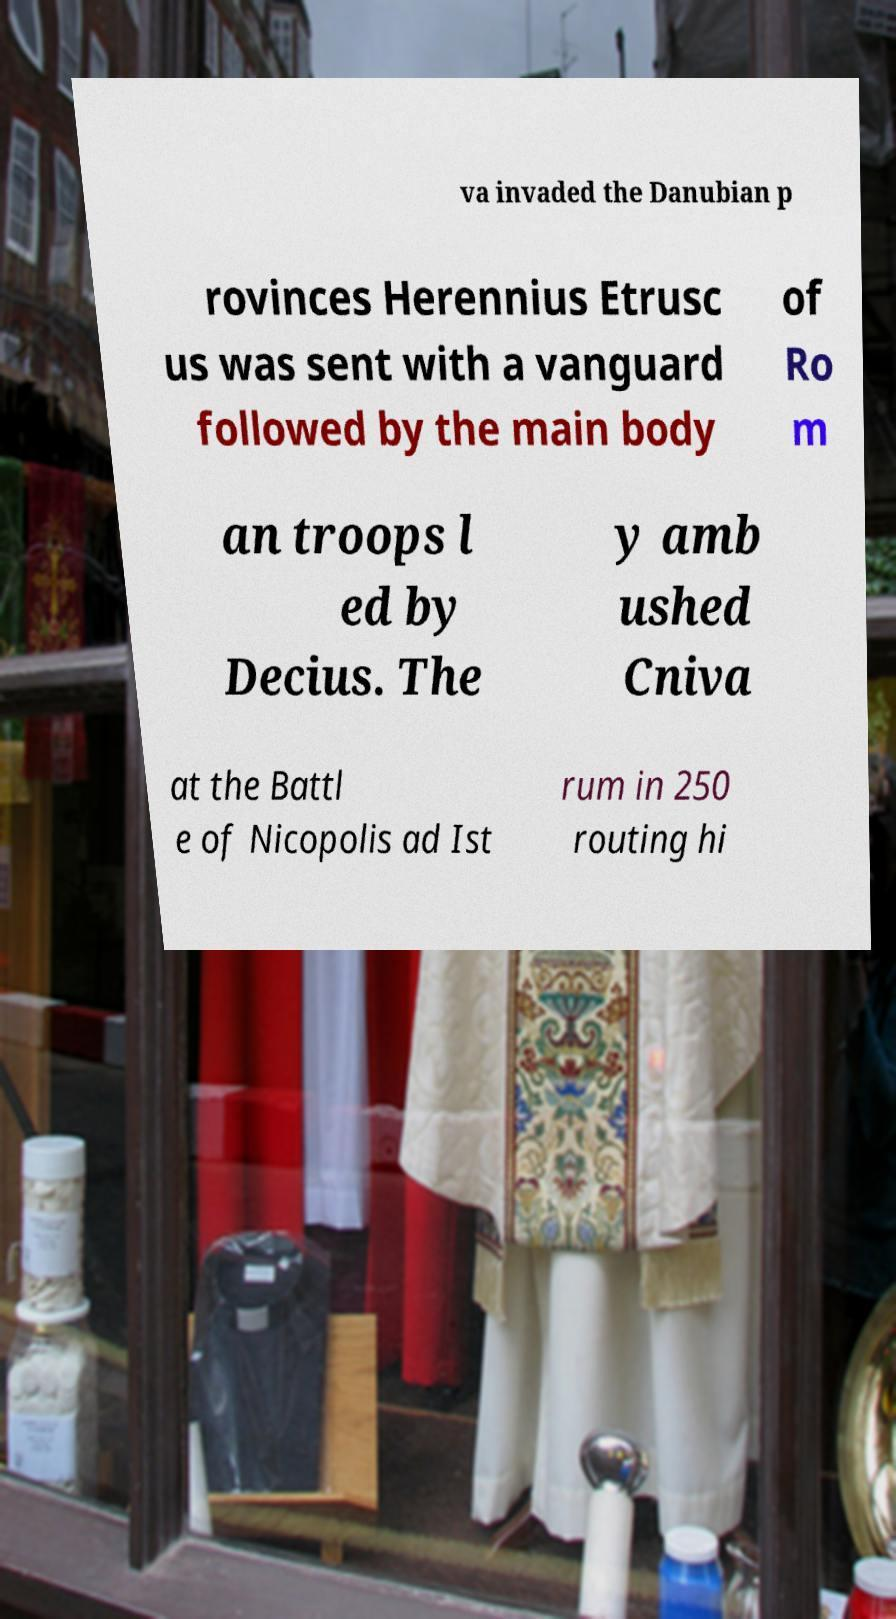Could you extract and type out the text from this image? va invaded the Danubian p rovinces Herennius Etrusc us was sent with a vanguard followed by the main body of Ro m an troops l ed by Decius. The y amb ushed Cniva at the Battl e of Nicopolis ad Ist rum in 250 routing hi 